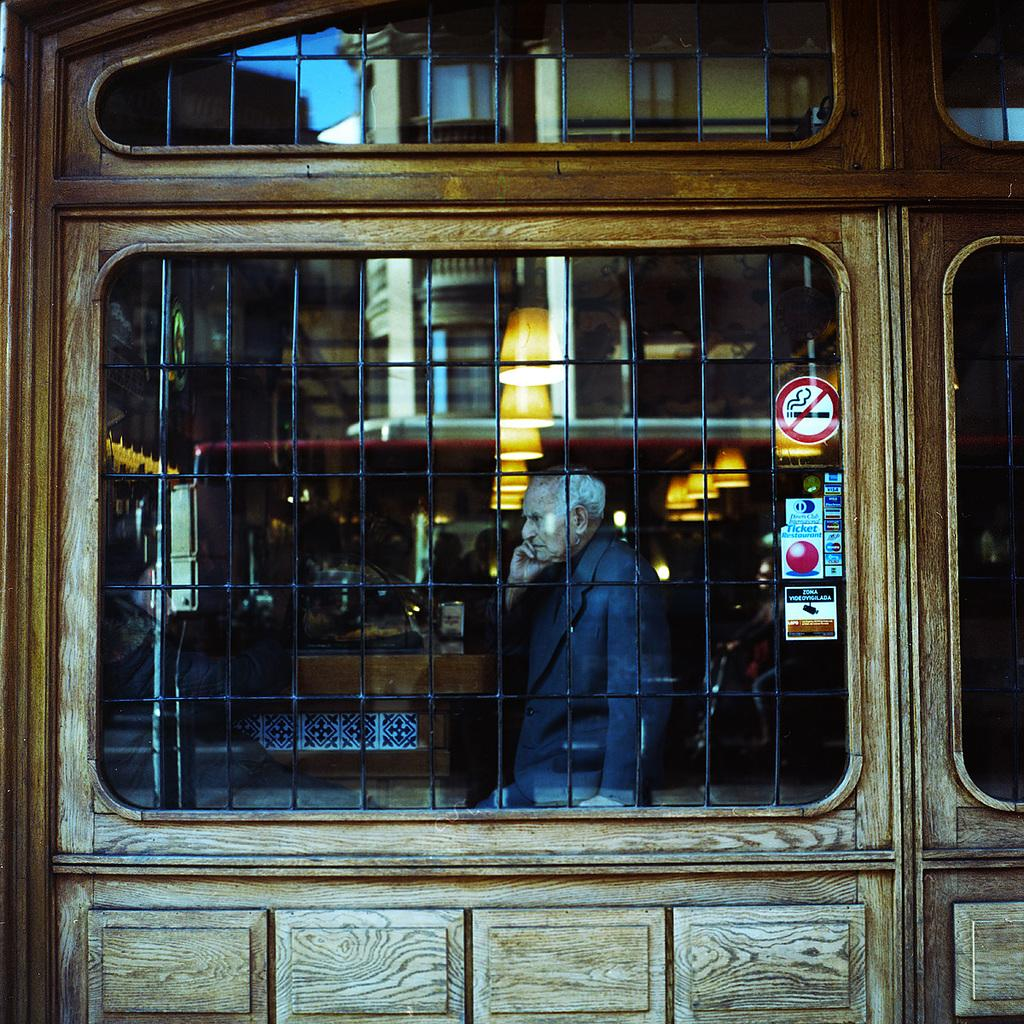What can be seen on the wall in the image? There is a mirror with grilles on the wall in the image. Can you describe the mirror in more detail? The mirror has grilles on it. Is there anyone visible in the image? Yes, a person is visible in the mirror. What level of attraction does the mirror have in the image? The mirror in the image does not have a level of attraction, as it is an inanimate object. 